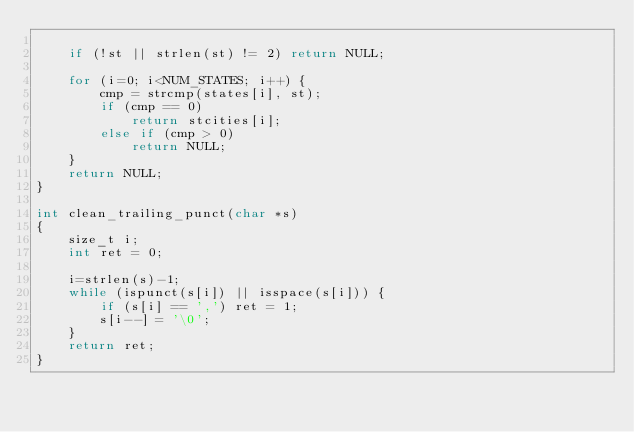Convert code to text. <code><loc_0><loc_0><loc_500><loc_500><_C_>
    if (!st || strlen(st) != 2) return NULL;

    for (i=0; i<NUM_STATES; i++) {
        cmp = strcmp(states[i], st);
        if (cmp == 0)
            return stcities[i];
        else if (cmp > 0)
            return NULL;
    }
    return NULL;
}

int clean_trailing_punct(char *s)
{
    size_t i;
    int ret = 0;

    i=strlen(s)-1;
    while (ispunct(s[i]) || isspace(s[i])) {
        if (s[i] == ',') ret = 1;
        s[i--] = '\0';
    }
    return ret;
}
</code> 